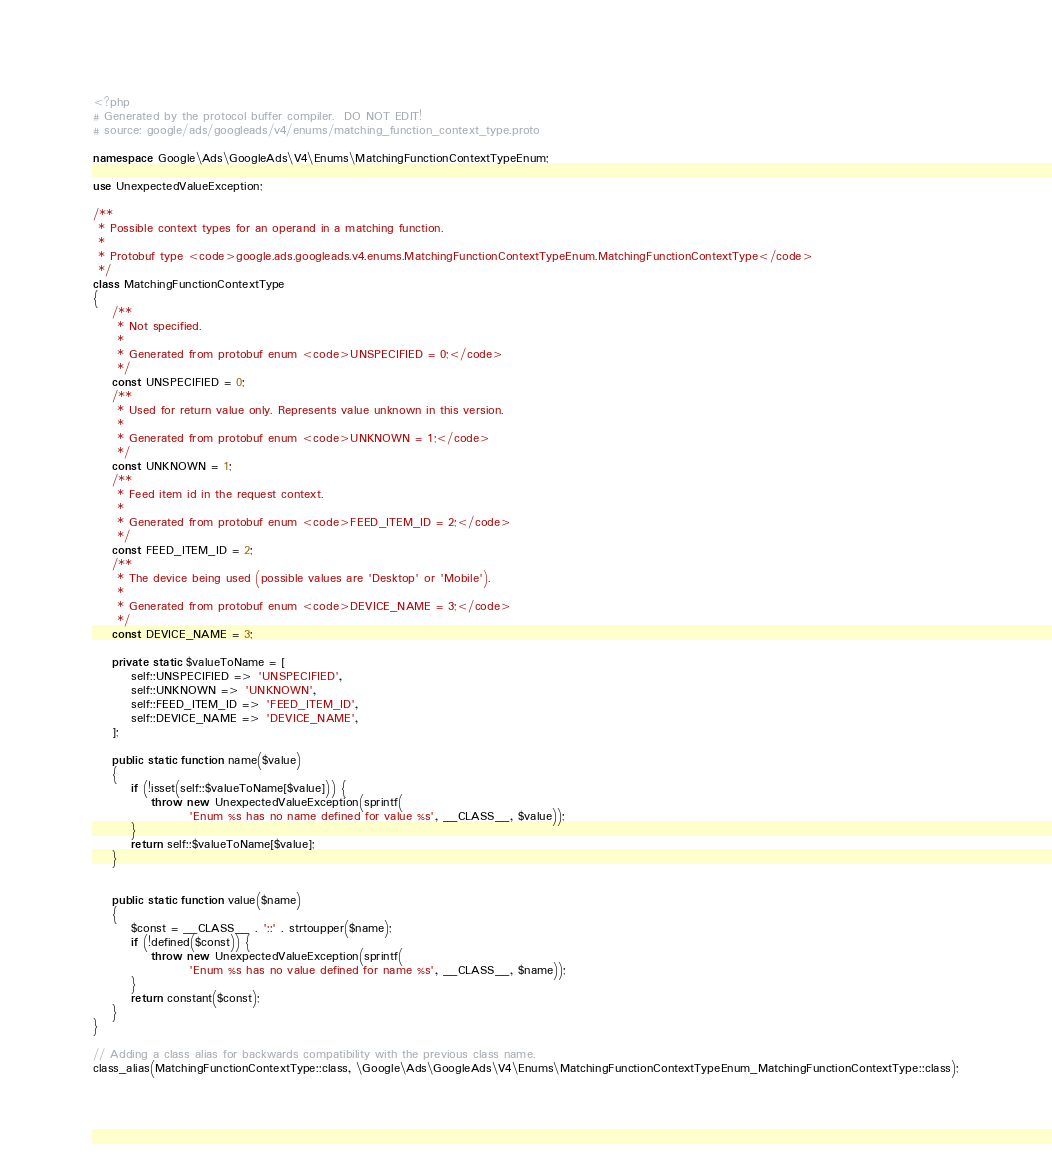<code> <loc_0><loc_0><loc_500><loc_500><_PHP_><?php
# Generated by the protocol buffer compiler.  DO NOT EDIT!
# source: google/ads/googleads/v4/enums/matching_function_context_type.proto

namespace Google\Ads\GoogleAds\V4\Enums\MatchingFunctionContextTypeEnum;

use UnexpectedValueException;

/**
 * Possible context types for an operand in a matching function.
 *
 * Protobuf type <code>google.ads.googleads.v4.enums.MatchingFunctionContextTypeEnum.MatchingFunctionContextType</code>
 */
class MatchingFunctionContextType
{
    /**
     * Not specified.
     *
     * Generated from protobuf enum <code>UNSPECIFIED = 0;</code>
     */
    const UNSPECIFIED = 0;
    /**
     * Used for return value only. Represents value unknown in this version.
     *
     * Generated from protobuf enum <code>UNKNOWN = 1;</code>
     */
    const UNKNOWN = 1;
    /**
     * Feed item id in the request context.
     *
     * Generated from protobuf enum <code>FEED_ITEM_ID = 2;</code>
     */
    const FEED_ITEM_ID = 2;
    /**
     * The device being used (possible values are 'Desktop' or 'Mobile').
     *
     * Generated from protobuf enum <code>DEVICE_NAME = 3;</code>
     */
    const DEVICE_NAME = 3;

    private static $valueToName = [
        self::UNSPECIFIED => 'UNSPECIFIED',
        self::UNKNOWN => 'UNKNOWN',
        self::FEED_ITEM_ID => 'FEED_ITEM_ID',
        self::DEVICE_NAME => 'DEVICE_NAME',
    ];

    public static function name($value)
    {
        if (!isset(self::$valueToName[$value])) {
            throw new UnexpectedValueException(sprintf(
                    'Enum %s has no name defined for value %s', __CLASS__, $value));
        }
        return self::$valueToName[$value];
    }


    public static function value($name)
    {
        $const = __CLASS__ . '::' . strtoupper($name);
        if (!defined($const)) {
            throw new UnexpectedValueException(sprintf(
                    'Enum %s has no value defined for name %s', __CLASS__, $name));
        }
        return constant($const);
    }
}

// Adding a class alias for backwards compatibility with the previous class name.
class_alias(MatchingFunctionContextType::class, \Google\Ads\GoogleAds\V4\Enums\MatchingFunctionContextTypeEnum_MatchingFunctionContextType::class);

</code> 